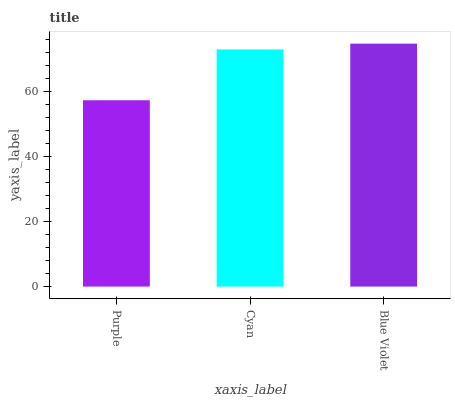Is Purple the minimum?
Answer yes or no. Yes. Is Blue Violet the maximum?
Answer yes or no. Yes. Is Cyan the minimum?
Answer yes or no. No. Is Cyan the maximum?
Answer yes or no. No. Is Cyan greater than Purple?
Answer yes or no. Yes. Is Purple less than Cyan?
Answer yes or no. Yes. Is Purple greater than Cyan?
Answer yes or no. No. Is Cyan less than Purple?
Answer yes or no. No. Is Cyan the high median?
Answer yes or no. Yes. Is Cyan the low median?
Answer yes or no. Yes. Is Blue Violet the high median?
Answer yes or no. No. Is Blue Violet the low median?
Answer yes or no. No. 